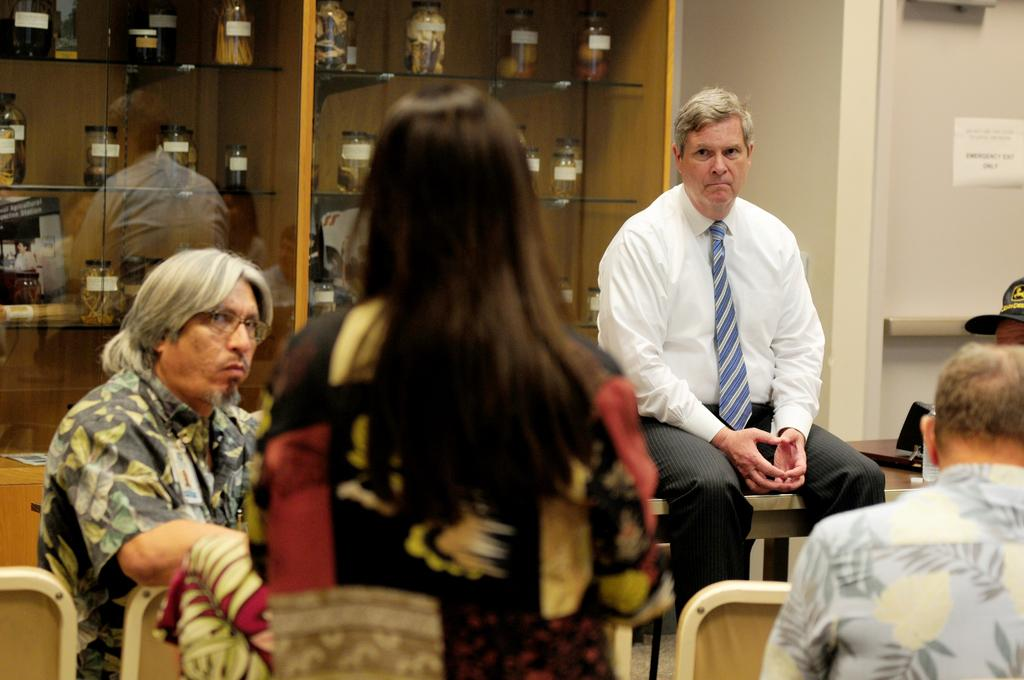What is the main subject in the foreground of the image? There is a person in the foreground of the image. What can be seen in the background of the image? There are people sitting in the background of the image, and there are glass bottles visible as well. What type of food is the person in the foreground eating in the image? There is no indication in the image that the person is eating any food, so it cannot be determined from the picture. 